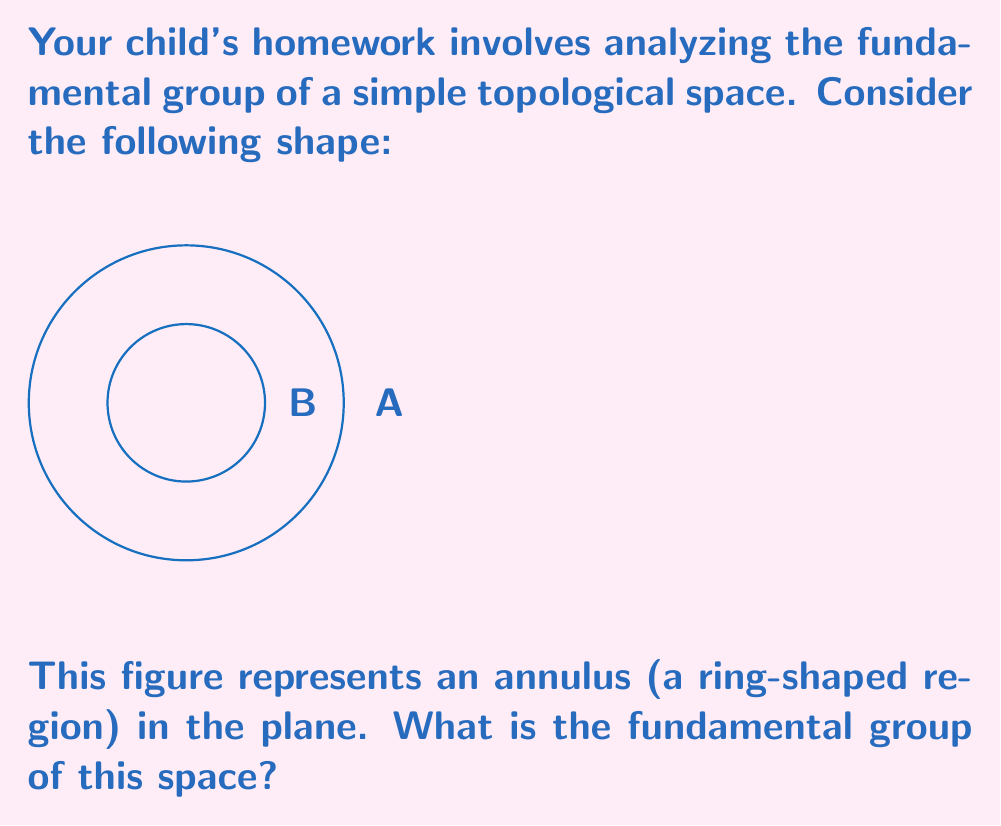Help me with this question. Let's approach this step-by-step:

1) First, recall that the fundamental group of a topological space consists of equivalence classes of loops based at a point, where two loops are equivalent if one can be continuously deformed into the other.

2) The annulus is topologically equivalent to a cylinder, as we can "straighten out" the ring without changing its essential properties.

3) To determine the fundamental group, we need to consider the different types of loops we can draw on this space:
   a) Loops that don't go around the hole can be contracted to a point.
   b) Loops that go around the hole cannot be contracted to a point.

4) The key observation is that loops going around the hole can be characterized by how many times they wind around, and in which direction.

5) Mathematically, we can represent this with the integers $\mathbb{Z}$:
   - A loop going once counterclockwise around the hole corresponds to 1.
   - A loop going twice counterclockwise corresponds to 2.
   - A loop going once clockwise corresponds to -1.
   - And so on...

6) The operation of concatenating loops corresponds to addition in $\mathbb{Z}$.

7) Therefore, the fundamental group of the annulus is isomorphic to $\mathbb{Z}$.

In topological notation, we write this as:

$$\pi_1(\text{Annulus}) \cong \mathbb{Z}$$

Where $\pi_1$ denotes the fundamental group and $\cong$ means "is isomorphic to".
Answer: $\mathbb{Z}$ 